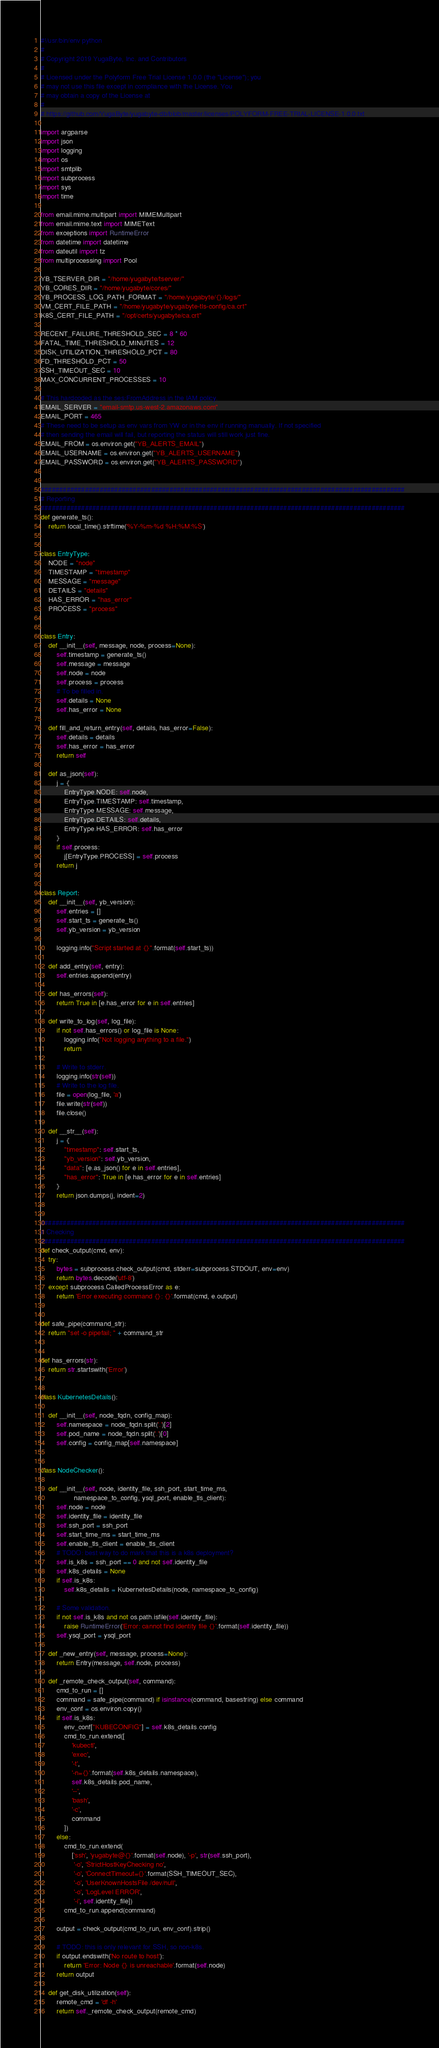Convert code to text. <code><loc_0><loc_0><loc_500><loc_500><_Python_>#!/usr/bin/env python
#
# Copyright 2019 YugaByte, Inc. and Contributors
#
# Licensed under the Polyform Free Trial License 1.0.0 (the "License"); you
# may not use this file except in compliance with the License. You
# may obtain a copy of the License at
#
# https://github.com/YugaByte/yugabyte-db/blob/master/licenses/POLYFORM-FREE-TRIAL-LICENSE-1.0.0.txt

import argparse
import json
import logging
import os
import smtplib
import subprocess
import sys
import time

from email.mime.multipart import MIMEMultipart
from email.mime.text import MIMEText
from exceptions import RuntimeError
from datetime import datetime
from dateutil import tz
from multiprocessing import Pool

YB_TSERVER_DIR = "/home/yugabyte/tserver/"
YB_CORES_DIR = "/home/yugabyte/cores/"
YB_PROCESS_LOG_PATH_FORMAT = "/home/yugabyte/{}/logs/"
VM_CERT_FILE_PATH = "/home/yugabyte/yugabyte-tls-config/ca.crt"
K8S_CERT_FILE_PATH = "/opt/certs/yugabyte/ca.crt"

RECENT_FAILURE_THRESHOLD_SEC = 8 * 60
FATAL_TIME_THRESHOLD_MINUTES = 12
DISK_UTILIZATION_THRESHOLD_PCT = 80
FD_THRESHOLD_PCT = 50
SSH_TIMEOUT_SEC = 10
MAX_CONCURRENT_PROCESSES = 10

# This hardcoded as the ses:FromAddress in the IAM policy.
EMAIL_SERVER = "email-smtp.us-west-2.amazonaws.com"
EMAIL_PORT = 465
# These need to be setup as env vars from YW or in the env if running manually. If not specified
# then sending the email will fail, but reporting the status will still work just fine.
EMAIL_FROM = os.environ.get("YB_ALERTS_EMAIL")
EMAIL_USERNAME = os.environ.get("YB_ALERTS_USERNAME")
EMAIL_PASSWORD = os.environ.get("YB_ALERTS_PASSWORD")


###################################################################################################
# Reporting
###################################################################################################
def generate_ts():
    return local_time().strftime('%Y-%m-%d %H:%M:%S')


class EntryType:
    NODE = "node"
    TIMESTAMP = "timestamp"
    MESSAGE = "message"
    DETAILS = "details"
    HAS_ERROR = "has_error"
    PROCESS = "process"


class Entry:
    def __init__(self, message, node, process=None):
        self.timestamp = generate_ts()
        self.message = message
        self.node = node
        self.process = process
        # To be filled in.
        self.details = None
        self.has_error = None

    def fill_and_return_entry(self, details, has_error=False):
        self.details = details
        self.has_error = has_error
        return self

    def as_json(self):
        j = {
            EntryType.NODE: self.node,
            EntryType.TIMESTAMP: self.timestamp,
            EntryType.MESSAGE: self.message,
            EntryType.DETAILS: self.details,
            EntryType.HAS_ERROR: self.has_error
        }
        if self.process:
            j[EntryType.PROCESS] = self.process
        return j


class Report:
    def __init__(self, yb_version):
        self.entries = []
        self.start_ts = generate_ts()
        self.yb_version = yb_version

        logging.info("Script started at {}".format(self.start_ts))

    def add_entry(self, entry):
        self.entries.append(entry)

    def has_errors(self):
        return True in [e.has_error for e in self.entries]

    def write_to_log(self, log_file):
        if not self.has_errors() or log_file is None:
            logging.info("Not logging anything to a file.")
            return

        # Write to stderr.
        logging.info(str(self))
        # Write to the log file.
        file = open(log_file, 'a')
        file.write(str(self))
        file.close()

    def __str__(self):
        j = {
            "timestamp": self.start_ts,
            "yb_version": self.yb_version,
            "data": [e.as_json() for e in self.entries],
            "has_error": True in [e.has_error for e in self.entries]
        }
        return json.dumps(j, indent=2)


###################################################################################################
# Checking
###################################################################################################
def check_output(cmd, env):
    try:
        bytes = subprocess.check_output(cmd, stderr=subprocess.STDOUT, env=env)
        return bytes.decode('utf-8')
    except subprocess.CalledProcessError as e:
        return 'Error executing command {}: {}'.format(cmd, e.output)


def safe_pipe(command_str):
    return "set -o pipefail; " + command_str


def has_errors(str):
    return str.startswith('Error')


class KubernetesDetails():

    def __init__(self, node_fqdn, config_map):
        self.namespace = node_fqdn.split('.')[2]
        self.pod_name = node_fqdn.split('.')[0]
        self.config = config_map[self.namespace]


class NodeChecker():

    def __init__(self, node, identity_file, ssh_port, start_time_ms,
                 namespace_to_config, ysql_port, enable_tls_client):
        self.node = node
        self.identity_file = identity_file
        self.ssh_port = ssh_port
        self.start_time_ms = start_time_ms
        self.enable_tls_client = enable_tls_client
        # TODO: best way to do mark that this is a k8s deployment?
        self.is_k8s = ssh_port == 0 and not self.identity_file
        self.k8s_details = None
        if self.is_k8s:
            self.k8s_details = KubernetesDetails(node, namespace_to_config)

        # Some validation.
        if not self.is_k8s and not os.path.isfile(self.identity_file):
            raise RuntimeError('Error: cannot find identity file {}'.format(self.identity_file))
        self.ysql_port = ysql_port

    def _new_entry(self, message, process=None):
        return Entry(message, self.node, process)

    def _remote_check_output(self, command):
        cmd_to_run = []
        command = safe_pipe(command) if isinstance(command, basestring) else command
        env_conf = os.environ.copy()
        if self.is_k8s:
            env_conf["KUBECONFIG"] = self.k8s_details.config
            cmd_to_run.extend([
                'kubectl',
                'exec',
                '-t',
                '-n={}'.format(self.k8s_details.namespace),
                self.k8s_details.pod_name,
                '--',
                'bash',
                '-c',
                command
            ])
        else:
            cmd_to_run.extend(
                ['ssh', 'yugabyte@{}'.format(self.node), '-p', str(self.ssh_port),
                 '-o', 'StrictHostKeyChecking no',
                 '-o', 'ConnectTimeout={}'.format(SSH_TIMEOUT_SEC),
                 '-o', 'UserKnownHostsFile /dev/null',
                 '-o', 'LogLevel ERROR',
                 '-i', self.identity_file])
            cmd_to_run.append(command)

        output = check_output(cmd_to_run, env_conf).strip()

        # TODO: this is only relevant for SSH, so non-k8s.
        if output.endswith('No route to host'):
            return 'Error: Node {} is unreachable'.format(self.node)
        return output

    def get_disk_utilization(self):
        remote_cmd = 'df -h'
        return self._remote_check_output(remote_cmd)
</code> 